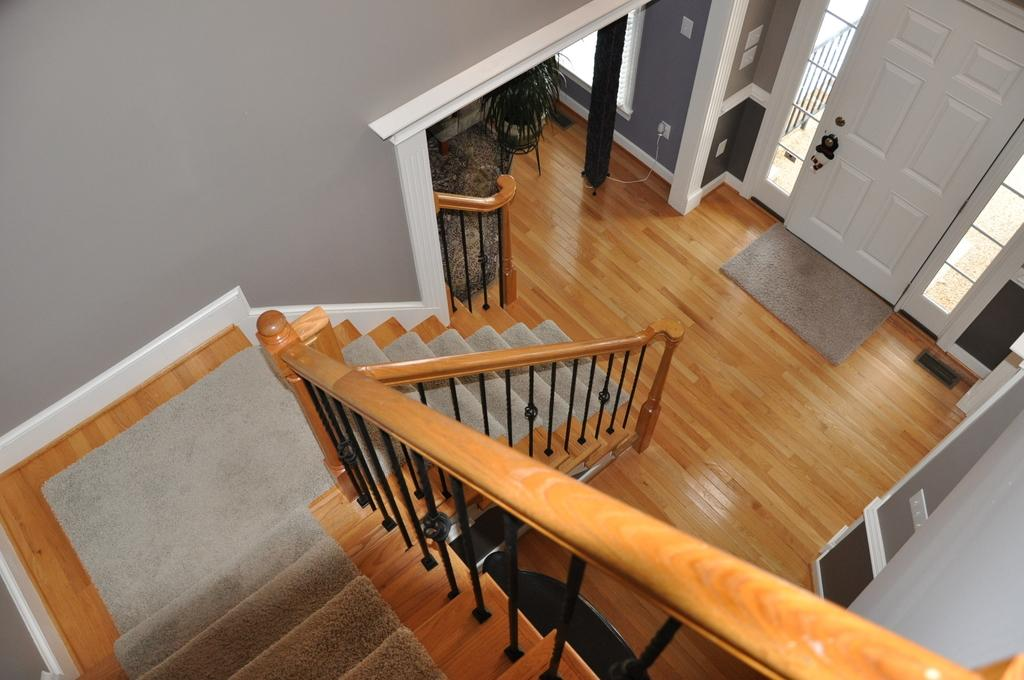What type of structure is present in the image? There is a staircase with railing in the image. What type of plant can be seen in the image? There is a plant in a pot in the image. What is the pole in the image used for? The purpose of the pole in the image is not specified, but it could be used for support or as a handrail. What type of electrical components are present in the image? There are switchboards on a wall in the image. What type of floor covering is present in the image? There is a mat on the floor in the image. What type of openings are present in the image? There is a window and a door in the image. Can you tell me how many family members are visible in the image? There is no family present in the image; it only features a staircase, a plant, a pole, switchboards, a mat, a window, and a door. What type of sponge is used to clean the windows in the image? There is no sponge visible in the image, and the cleaning method for the window is not specified. 